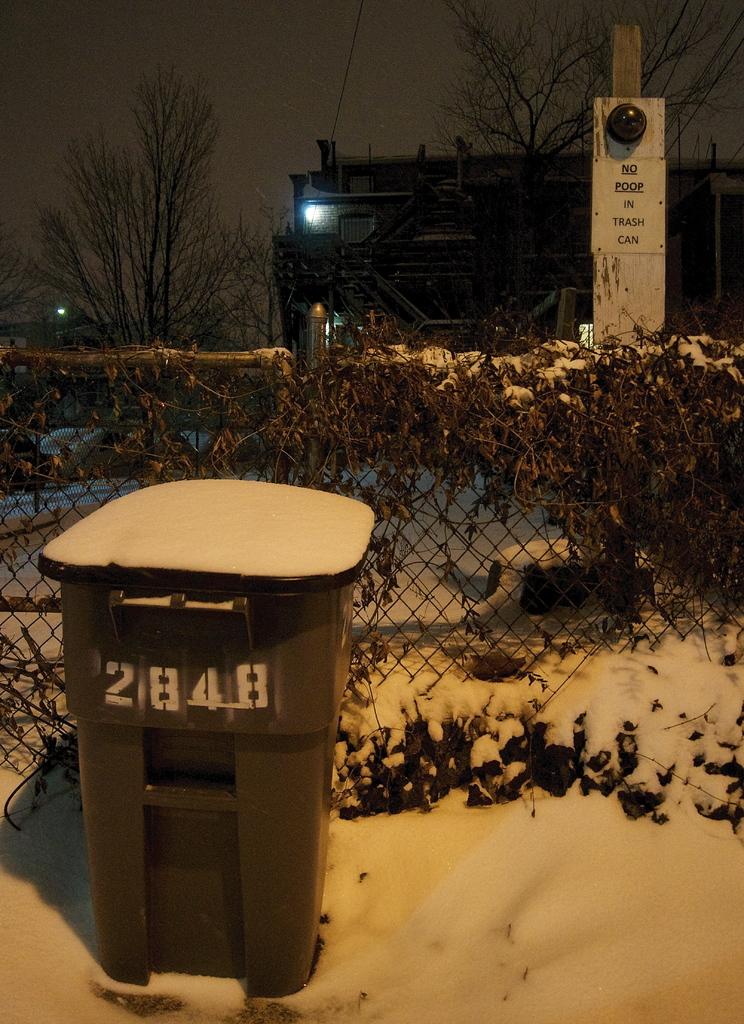What number is on the bin?
Ensure brevity in your answer.  2848. What does the sign say in the back say not to do?
Your response must be concise. No poop in trash can. 